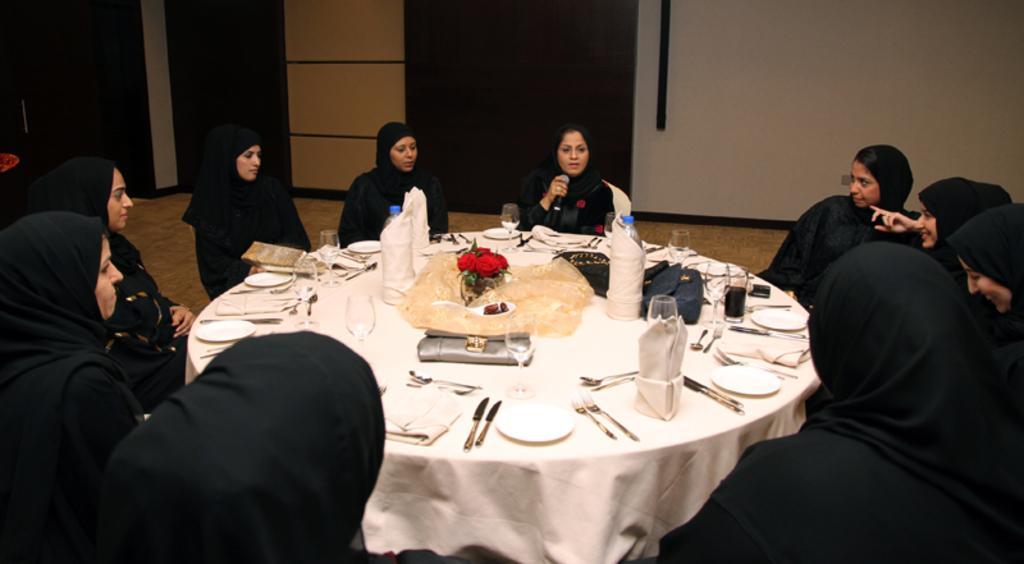Could you give a brief overview of what you see in this image? In this picture there are a group of people sitting in a circle and they have a table in front of them which has two water bottles some glass, plate, knife, napkins, spoons also there is a beverage glass and in the background there are doors and there is a wall 